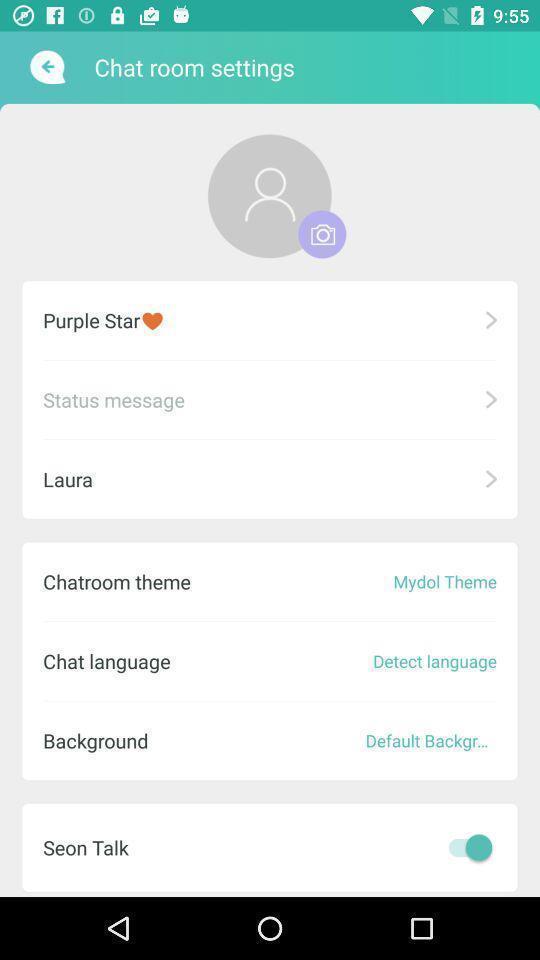Give me a narrative description of this picture. Setting page of chat room for an app. 